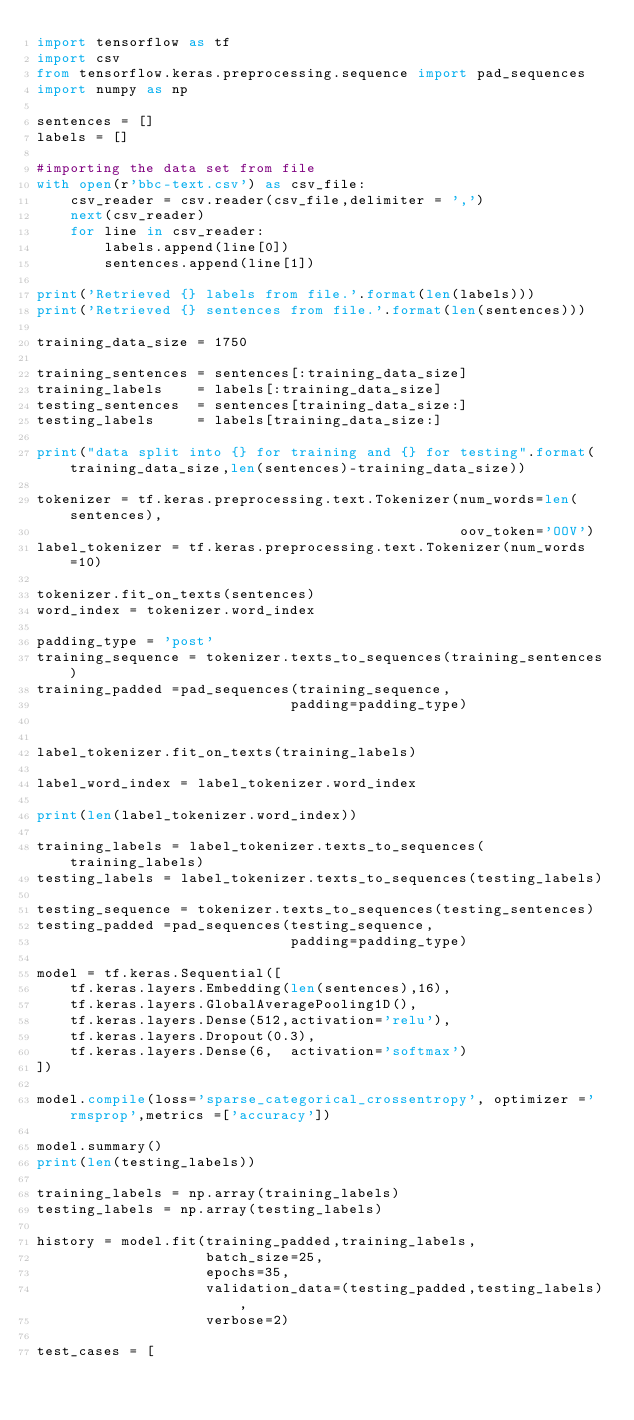Convert code to text. <code><loc_0><loc_0><loc_500><loc_500><_Python_>import tensorflow as tf
import csv
from tensorflow.keras.preprocessing.sequence import pad_sequences
import numpy as np

sentences = []
labels = []

#importing the data set from file
with open(r'bbc-text.csv') as csv_file:
    csv_reader = csv.reader(csv_file,delimiter = ',')
    next(csv_reader)
    for line in csv_reader:
        labels.append(line[0])
        sentences.append(line[1])

print('Retrieved {} labels from file.'.format(len(labels)))
print('Retrieved {} sentences from file.'.format(len(sentences)))

training_data_size = 1750

training_sentences = sentences[:training_data_size]
training_labels    = labels[:training_data_size]
testing_sentences  = sentences[training_data_size:]
testing_labels     = labels[training_data_size:]

print("data split into {} for training and {} for testing".format(training_data_size,len(sentences)-training_data_size))

tokenizer = tf.keras.preprocessing.text.Tokenizer(num_words=len(sentences),
                                                  oov_token='OOV')
label_tokenizer = tf.keras.preprocessing.text.Tokenizer(num_words=10)

tokenizer.fit_on_texts(sentences)
word_index = tokenizer.word_index

padding_type = 'post'
training_sequence = tokenizer.texts_to_sequences(training_sentences)
training_padded =pad_sequences(training_sequence,
                              padding=padding_type)


label_tokenizer.fit_on_texts(training_labels)

label_word_index = label_tokenizer.word_index

print(len(label_tokenizer.word_index))

training_labels = label_tokenizer.texts_to_sequences(training_labels)
testing_labels = label_tokenizer.texts_to_sequences(testing_labels)

testing_sequence = tokenizer.texts_to_sequences(testing_sentences)
testing_padded =pad_sequences(testing_sequence,
                              padding=padding_type)

model = tf.keras.Sequential([
    tf.keras.layers.Embedding(len(sentences),16),
    tf.keras.layers.GlobalAveragePooling1D(),
    tf.keras.layers.Dense(512,activation='relu'),
    tf.keras.layers.Dropout(0.3),
    tf.keras.layers.Dense(6,  activation='softmax')
])

model.compile(loss='sparse_categorical_crossentropy', optimizer ='rmsprop',metrics =['accuracy'])

model.summary()
print(len(testing_labels))

training_labels = np.array(training_labels)
testing_labels = np.array(testing_labels)

history = model.fit(training_padded,training_labels,
                    batch_size=25,
                    epochs=35,
                    validation_data=(testing_padded,testing_labels),
                    verbose=2)

test_cases = [</code> 